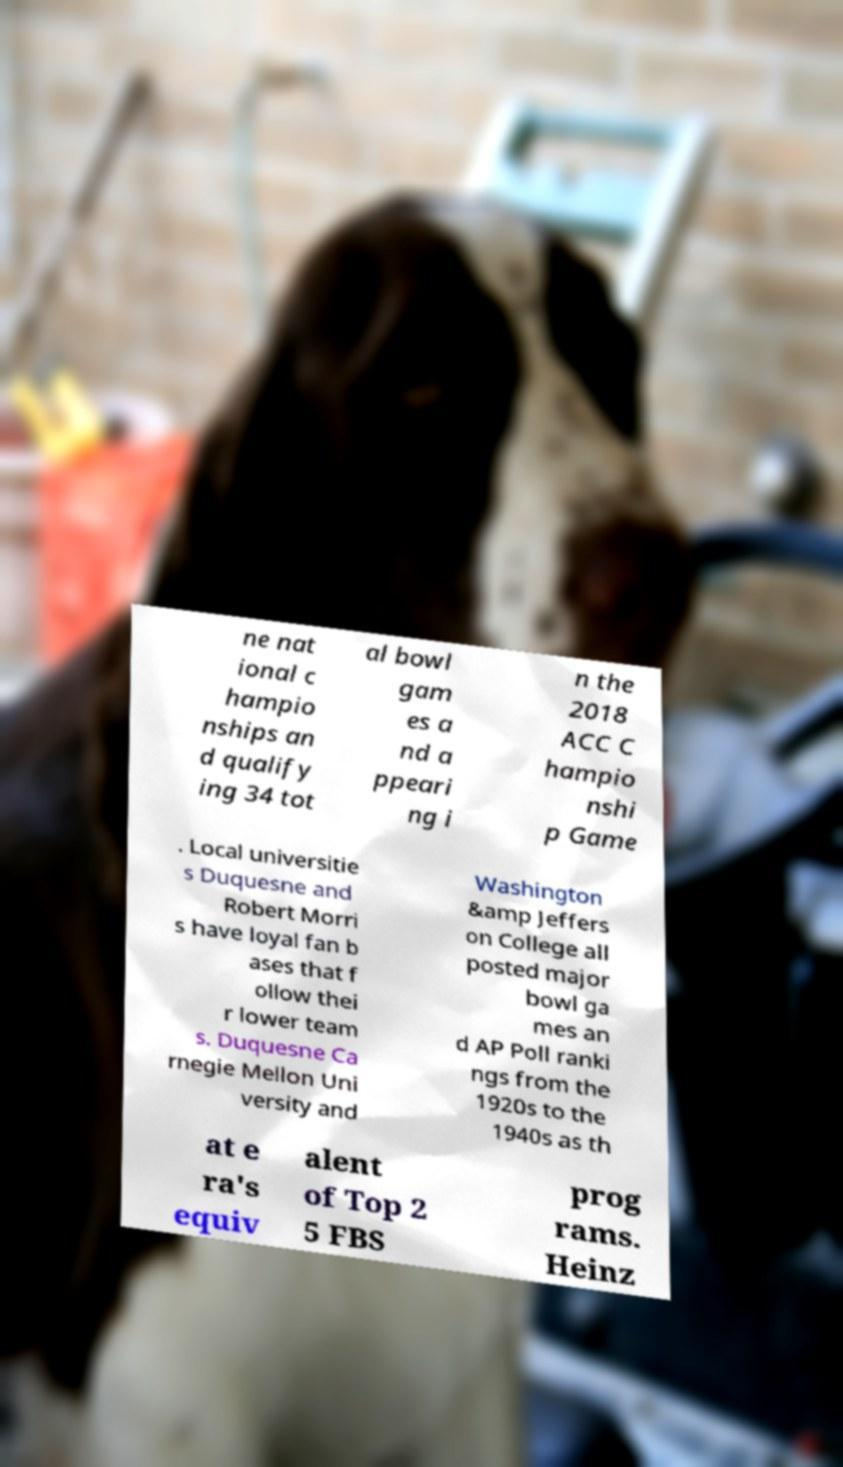Please identify and transcribe the text found in this image. ne nat ional c hampio nships an d qualify ing 34 tot al bowl gam es a nd a ppeari ng i n the 2018 ACC C hampio nshi p Game . Local universitie s Duquesne and Robert Morri s have loyal fan b ases that f ollow thei r lower team s. Duquesne Ca rnegie Mellon Uni versity and Washington &amp Jeffers on College all posted major bowl ga mes an d AP Poll ranki ngs from the 1920s to the 1940s as th at e ra's equiv alent of Top 2 5 FBS prog rams. Heinz 